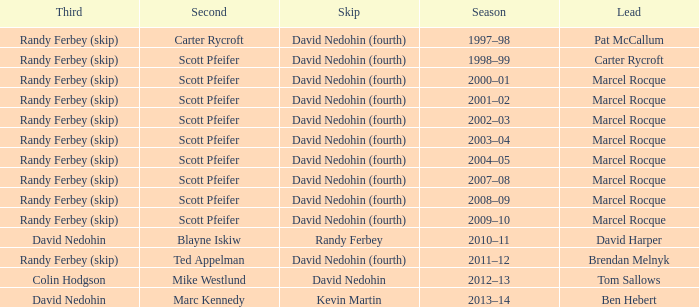Which Skip has a Season of 2002–03? David Nedohin (fourth). 